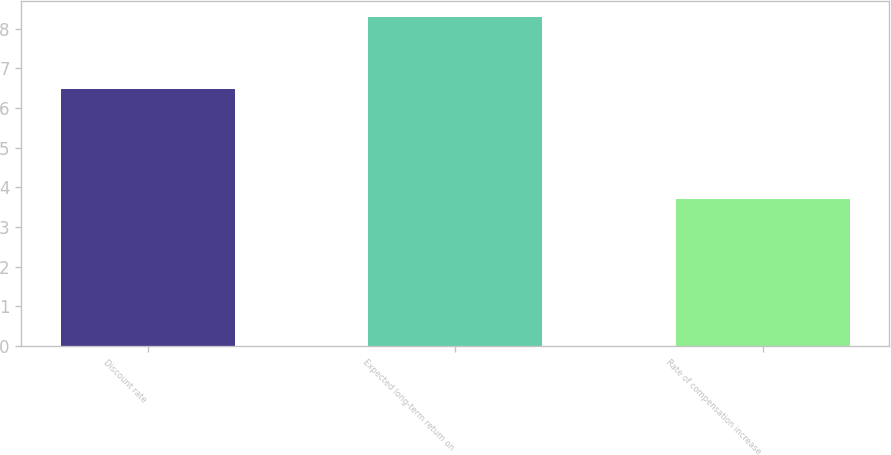<chart> <loc_0><loc_0><loc_500><loc_500><bar_chart><fcel>Discount rate<fcel>Expected long-term return on<fcel>Rate of compensation increase<nl><fcel>6.47<fcel>8.29<fcel>3.7<nl></chart> 